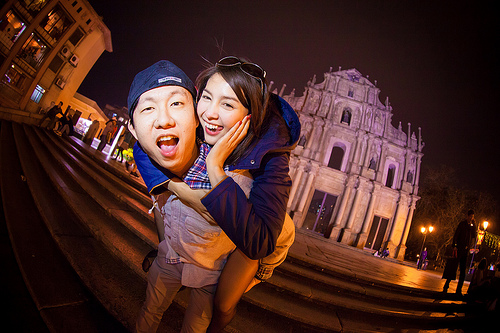<image>
Is there a man on the women? Yes. Looking at the image, I can see the man is positioned on top of the women, with the women providing support. Is there a jacket on the man? No. The jacket is not positioned on the man. They may be near each other, but the jacket is not supported by or resting on top of the man. 